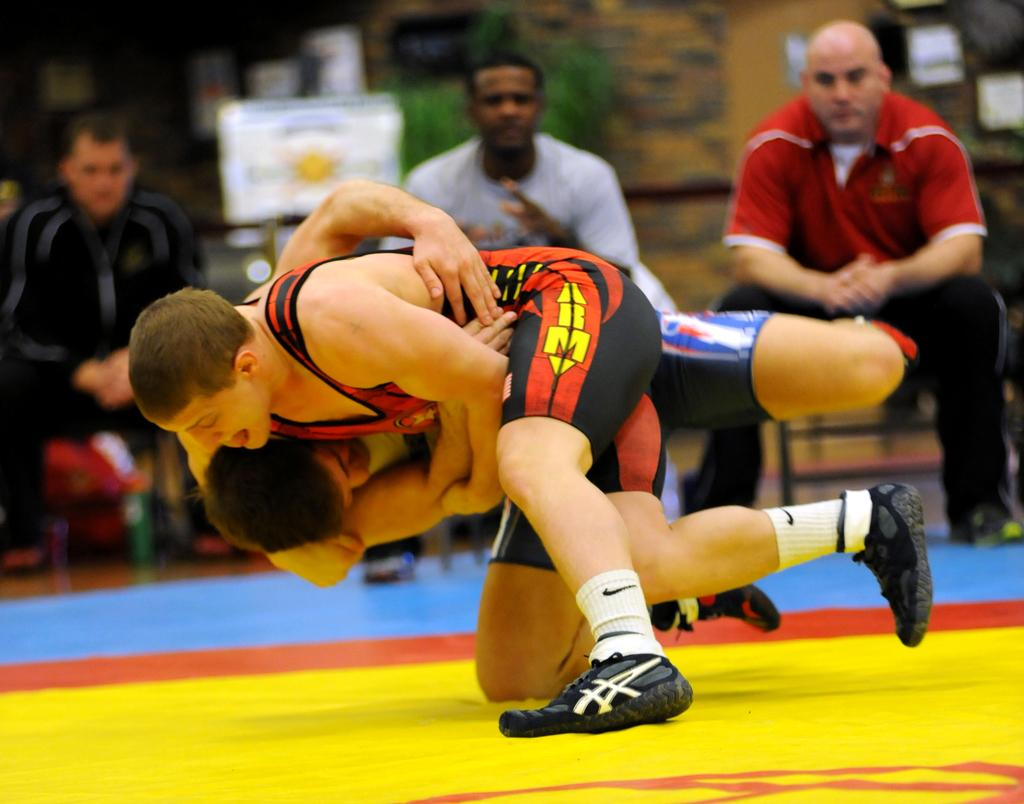What are the main subjects in the center of the image? There are people wrestling in the center of the image. What are the people in the background of the image doing? The people sitting in the background of the image. What object can be seen in the background of the image? There is a board visible in the background of the image. What type of pickle is being used as a prop in the wrestling match? There is no pickle present in the image, and it is not being used as a prop in the wrestling match. 